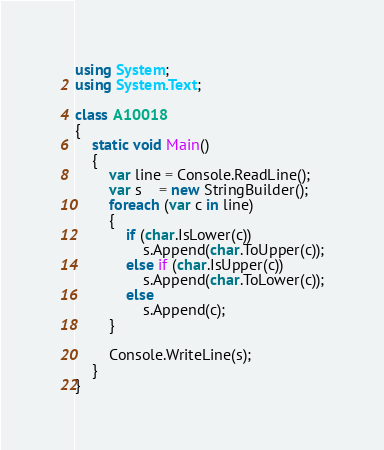Convert code to text. <code><loc_0><loc_0><loc_500><loc_500><_C#_>using System;
using System.Text; 

class A10018
{
	static void Main()
	{
		var line = Console.ReadLine();
		var s    = new StringBuilder();
		foreach (var c in line)
		{
			if (char.IsLower(c))
				s.Append(char.ToUpper(c));
			else if (char.IsUpper(c))
				s.Append(char.ToLower(c));
			else
				s.Append(c);
		}

		Console.WriteLine(s);
	}
}</code> 